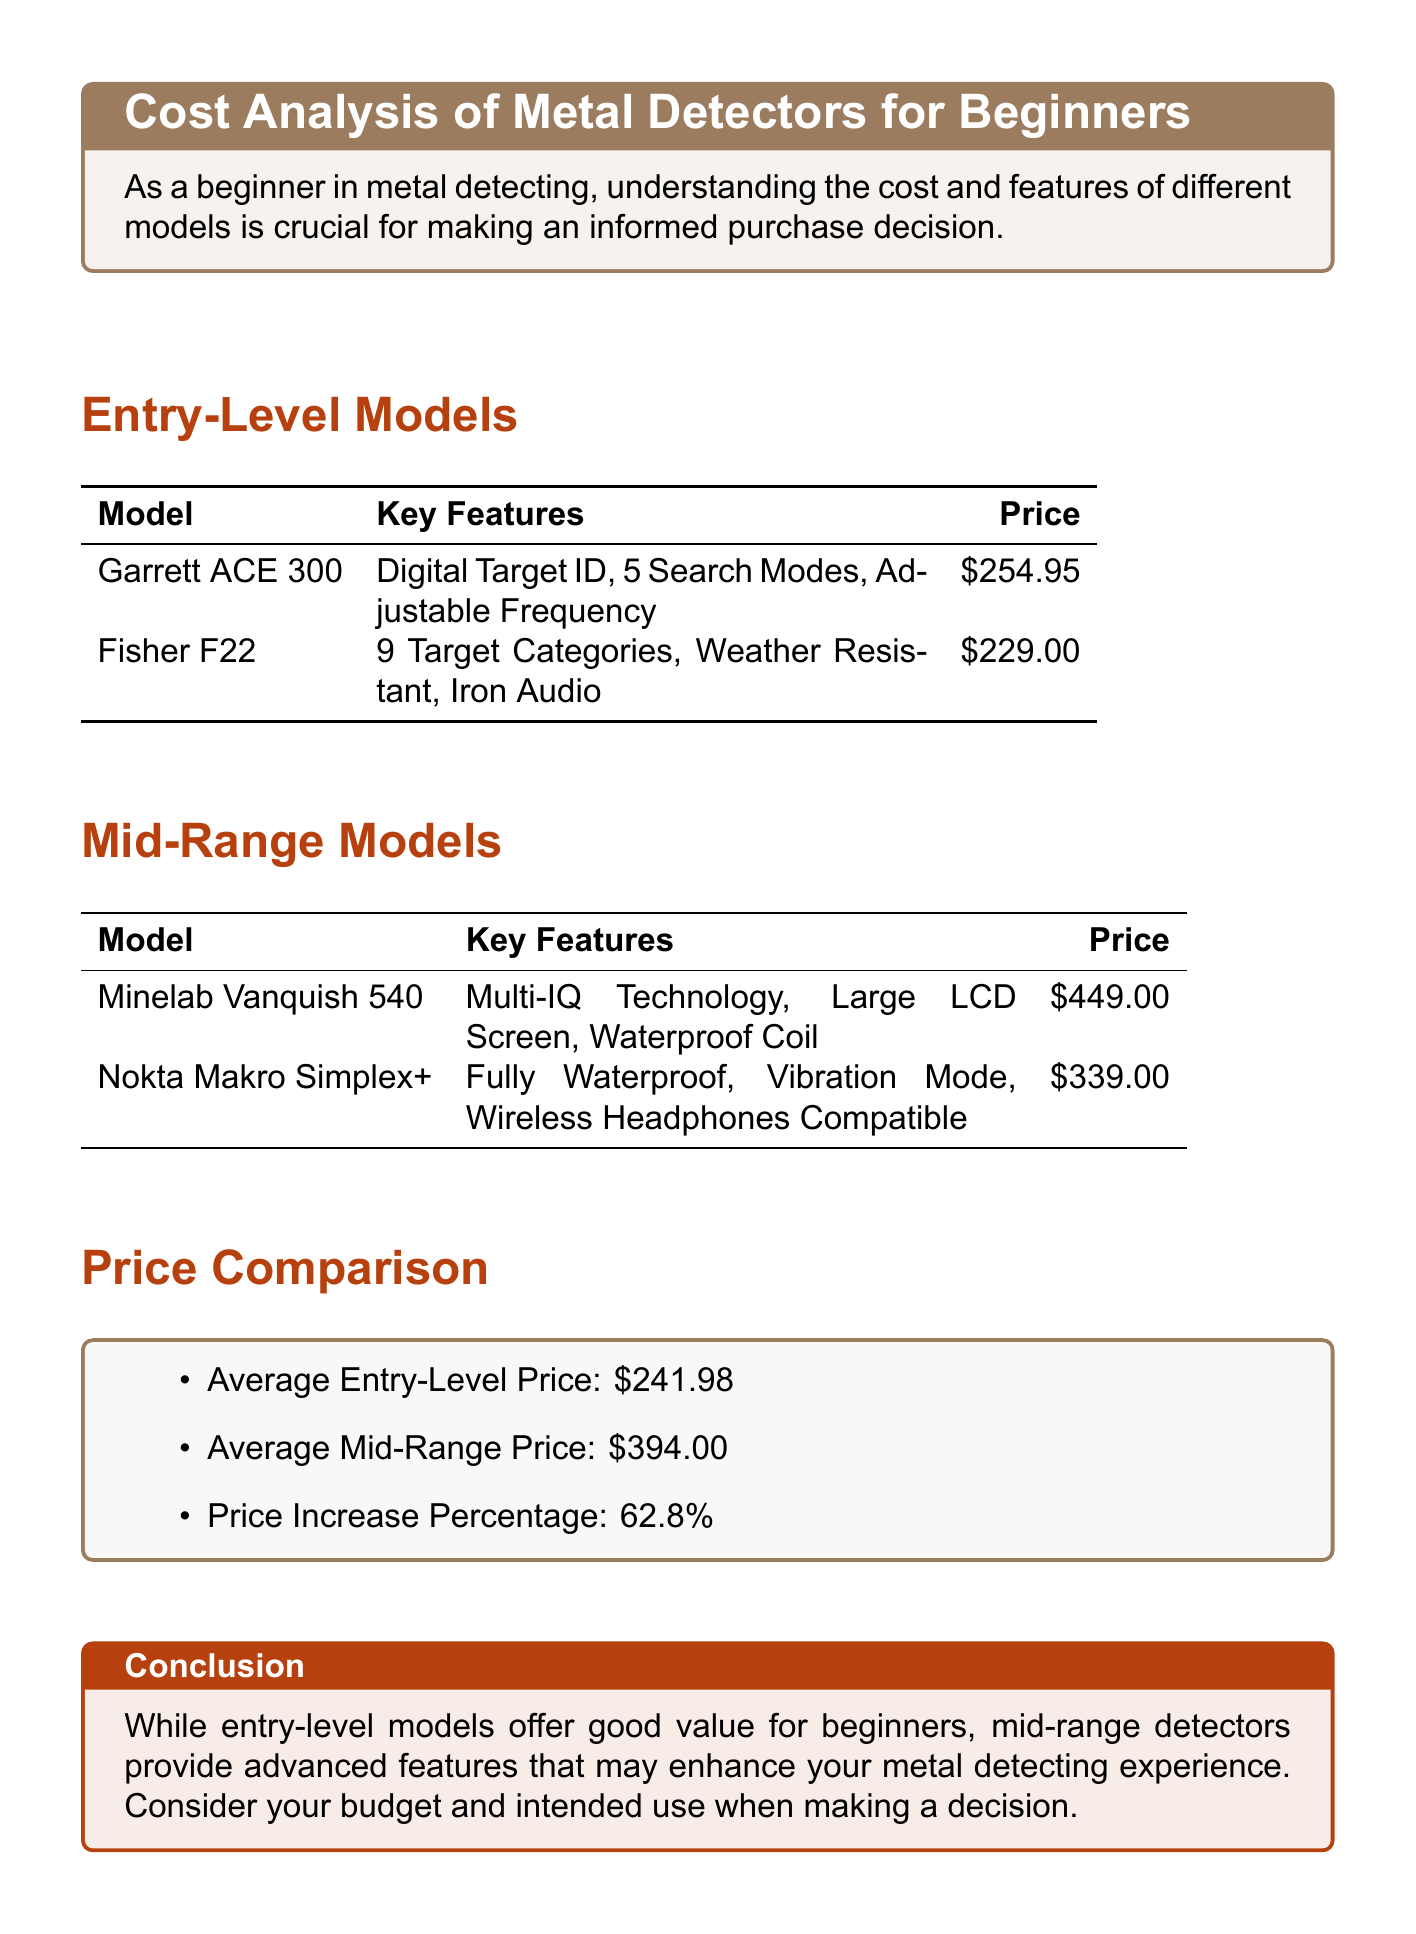What is the price of Garrett ACE 300? The price of Garrett ACE 300 is listed in the entry-level models section of the document.
Answer: $254.95 What key feature does Fisher F22 offer? Fisher F22's key features are listed in the entry-level models section, one of which is "Iron Audio."
Answer: Iron Audio What is the average price of mid-range models? The average price of mid-range models is provided in the price comparison section of the document.
Answer: $394.00 Which model is fully waterproof? The document lists several models with their features, and Nokta Makro Simplex+ is noted as fully waterproof.
Answer: Nokta Makro Simplex+ What is the price increase percentage from entry-level to mid-range models? The price increase percentage is found in the price comparison section, indicating the difference between the two categories.
Answer: 62.8% Which model has a large LCD screen? The mid-range models section mentions the Minelab Vanquish 540 as having a large LCD screen among its features.
Answer: Minelab Vanquish 540 What is the average entry-level price? The average entry-level price can be found in the price comparison section of the document.
Answer: $241.98 What should be considered when making a metal detector purchase decision? The conclusion section provides guidance for beginners regarding their purchase decisions.
Answer: Budget and intended use 